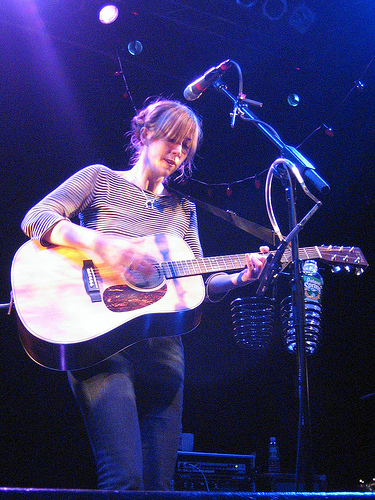<image>
Can you confirm if the microphone is in the stand? Yes. The microphone is contained within or inside the stand, showing a containment relationship. 